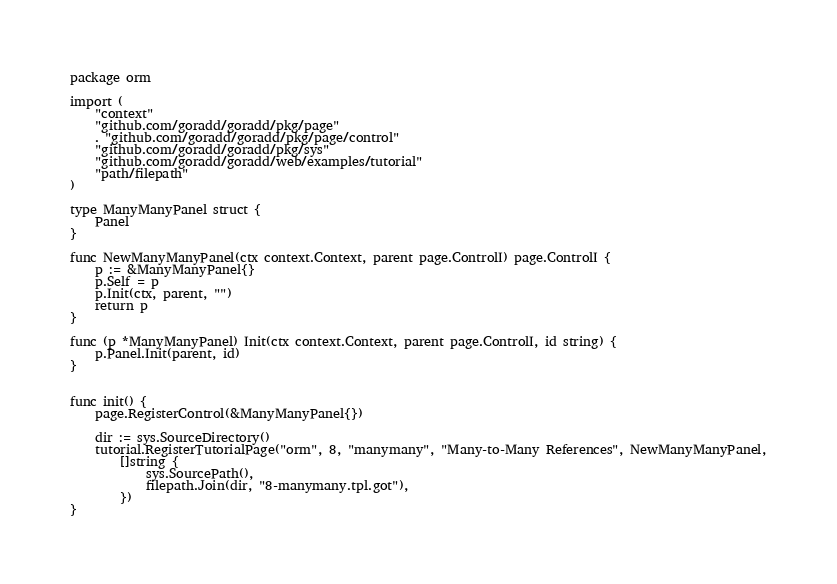<code> <loc_0><loc_0><loc_500><loc_500><_Go_>package orm

import (
	"context"
	"github.com/goradd/goradd/pkg/page"
	. "github.com/goradd/goradd/pkg/page/control"
	"github.com/goradd/goradd/pkg/sys"
	"github.com/goradd/goradd/web/examples/tutorial"
	"path/filepath"
)

type ManyManyPanel struct {
	Panel
}

func NewManyManyPanel(ctx context.Context, parent page.ControlI) page.ControlI {
	p := &ManyManyPanel{}
	p.Self = p
	p.Init(ctx, parent, "")
	return p
}

func (p *ManyManyPanel) Init(ctx context.Context, parent page.ControlI, id string) {
	p.Panel.Init(parent, id)
}


func init() {
	page.RegisterControl(&ManyManyPanel{})

	dir := sys.SourceDirectory()
	tutorial.RegisterTutorialPage("orm", 8, "manymany", "Many-to-Many References", NewManyManyPanel,
		[]string {
			sys.SourcePath(),
			filepath.Join(dir, "8-manymany.tpl.got"),
		})
}

</code> 